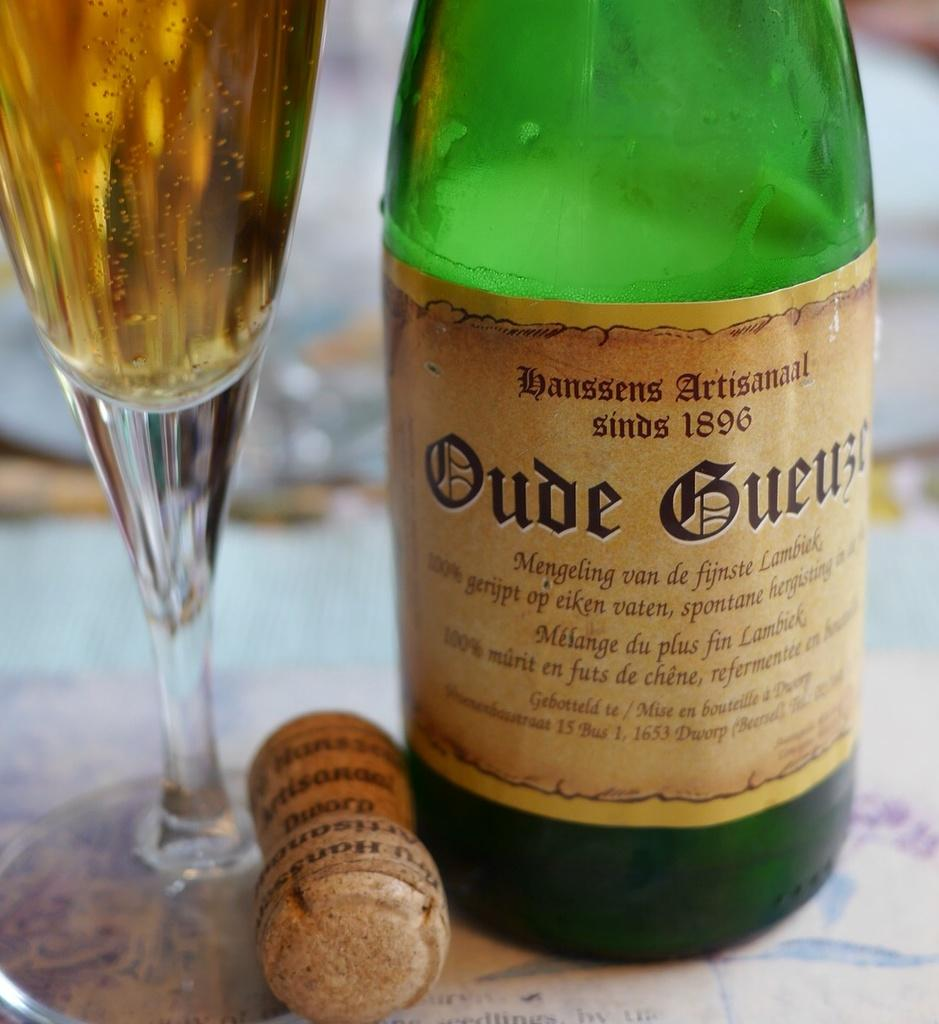<image>
Give a short and clear explanation of the subsequent image. A green glass bottle of Oude Guebe champagne with the cork out next to a champagne flute style glass. 